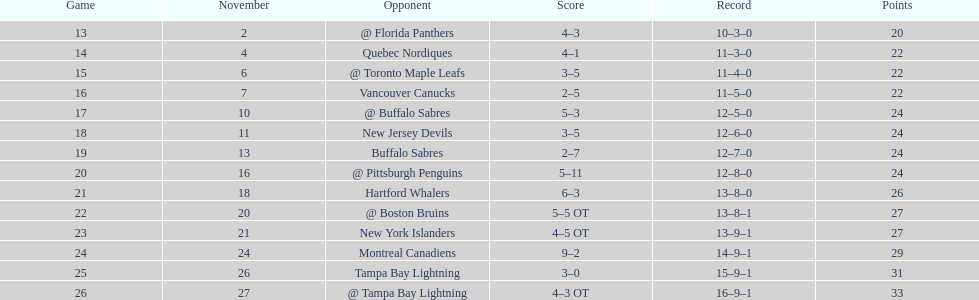Who had the most assists on the 1993-1994 flyers? Mark Recchi. 